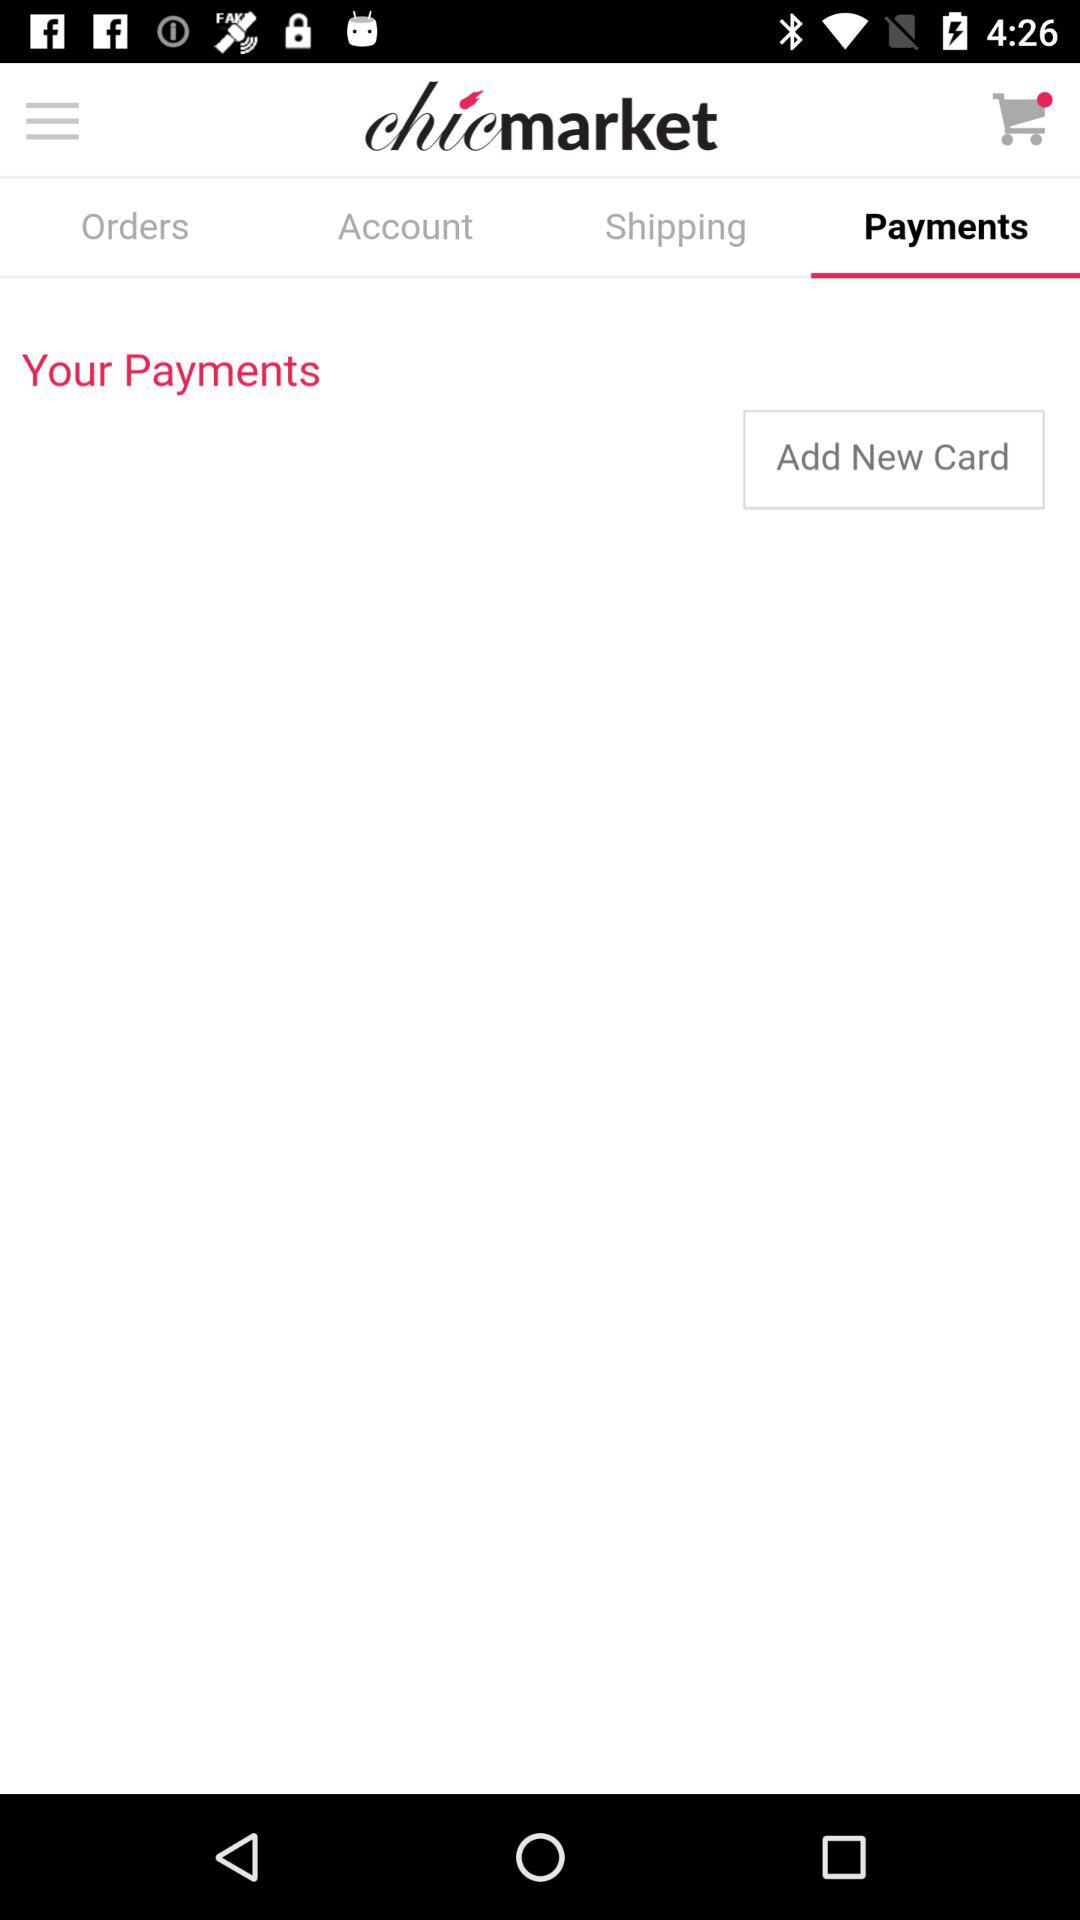What is the name of the application? The name of the application is "chicmarket". 